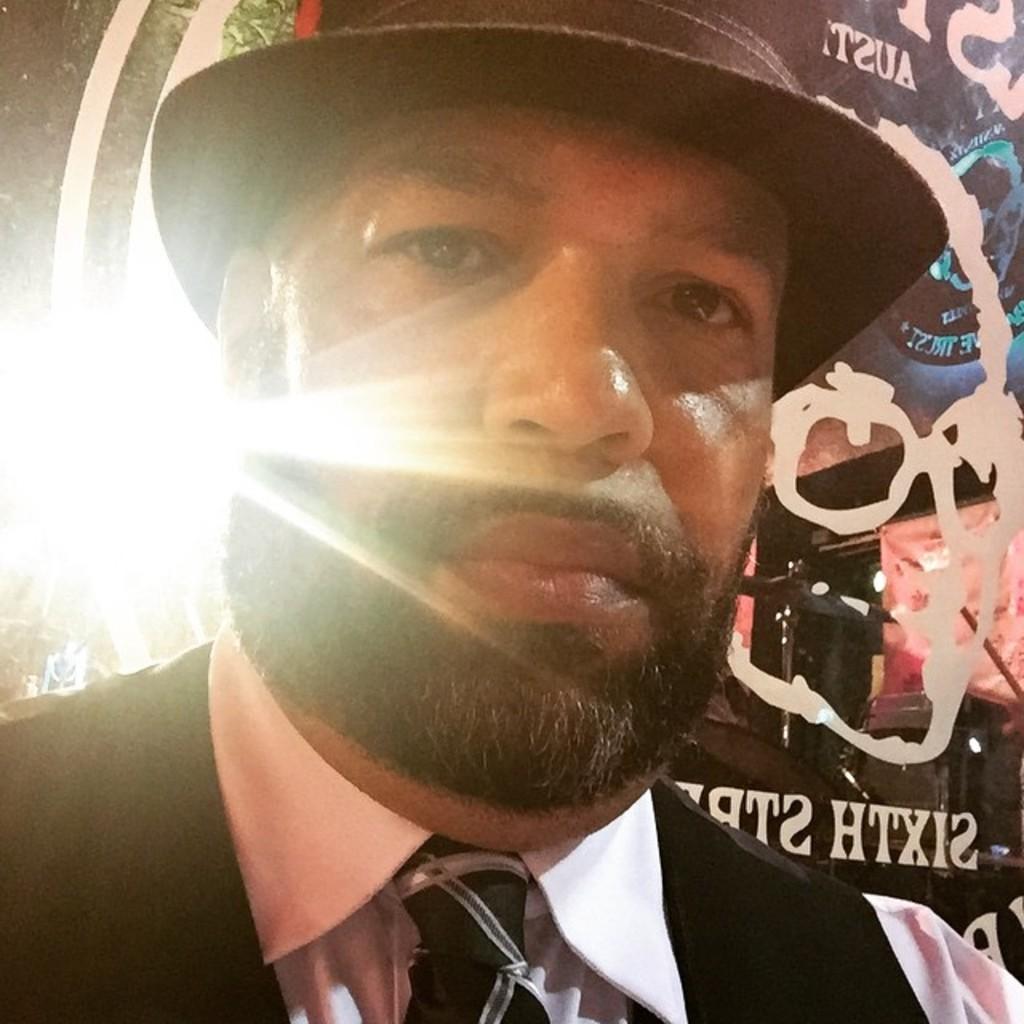In one or two sentences, can you explain what this image depicts? In the image there is a man in the foreground, behind him there is some poster. 